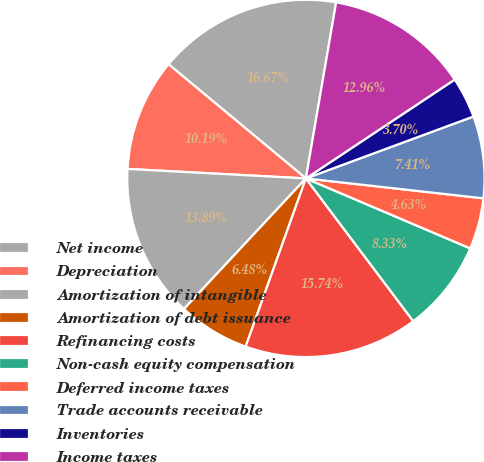Convert chart to OTSL. <chart><loc_0><loc_0><loc_500><loc_500><pie_chart><fcel>Net income<fcel>Depreciation<fcel>Amortization of intangible<fcel>Amortization of debt issuance<fcel>Refinancing costs<fcel>Non-cash equity compensation<fcel>Deferred income taxes<fcel>Trade accounts receivable<fcel>Inventories<fcel>Income taxes<nl><fcel>16.67%<fcel>10.19%<fcel>13.89%<fcel>6.48%<fcel>15.74%<fcel>8.33%<fcel>4.63%<fcel>7.41%<fcel>3.7%<fcel>12.96%<nl></chart> 